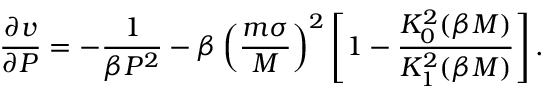<formula> <loc_0><loc_0><loc_500><loc_500>\frac { \partial v } { \partial P } = - \frac { 1 } { \beta P ^ { 2 } } - \beta \left ( \frac { m \sigma } { M } \right ) ^ { 2 } \left [ 1 - \frac { K _ { 0 } ^ { 2 } ( \beta M ) } { K _ { 1 } ^ { 2 } ( \beta M ) } \right ] .</formula> 